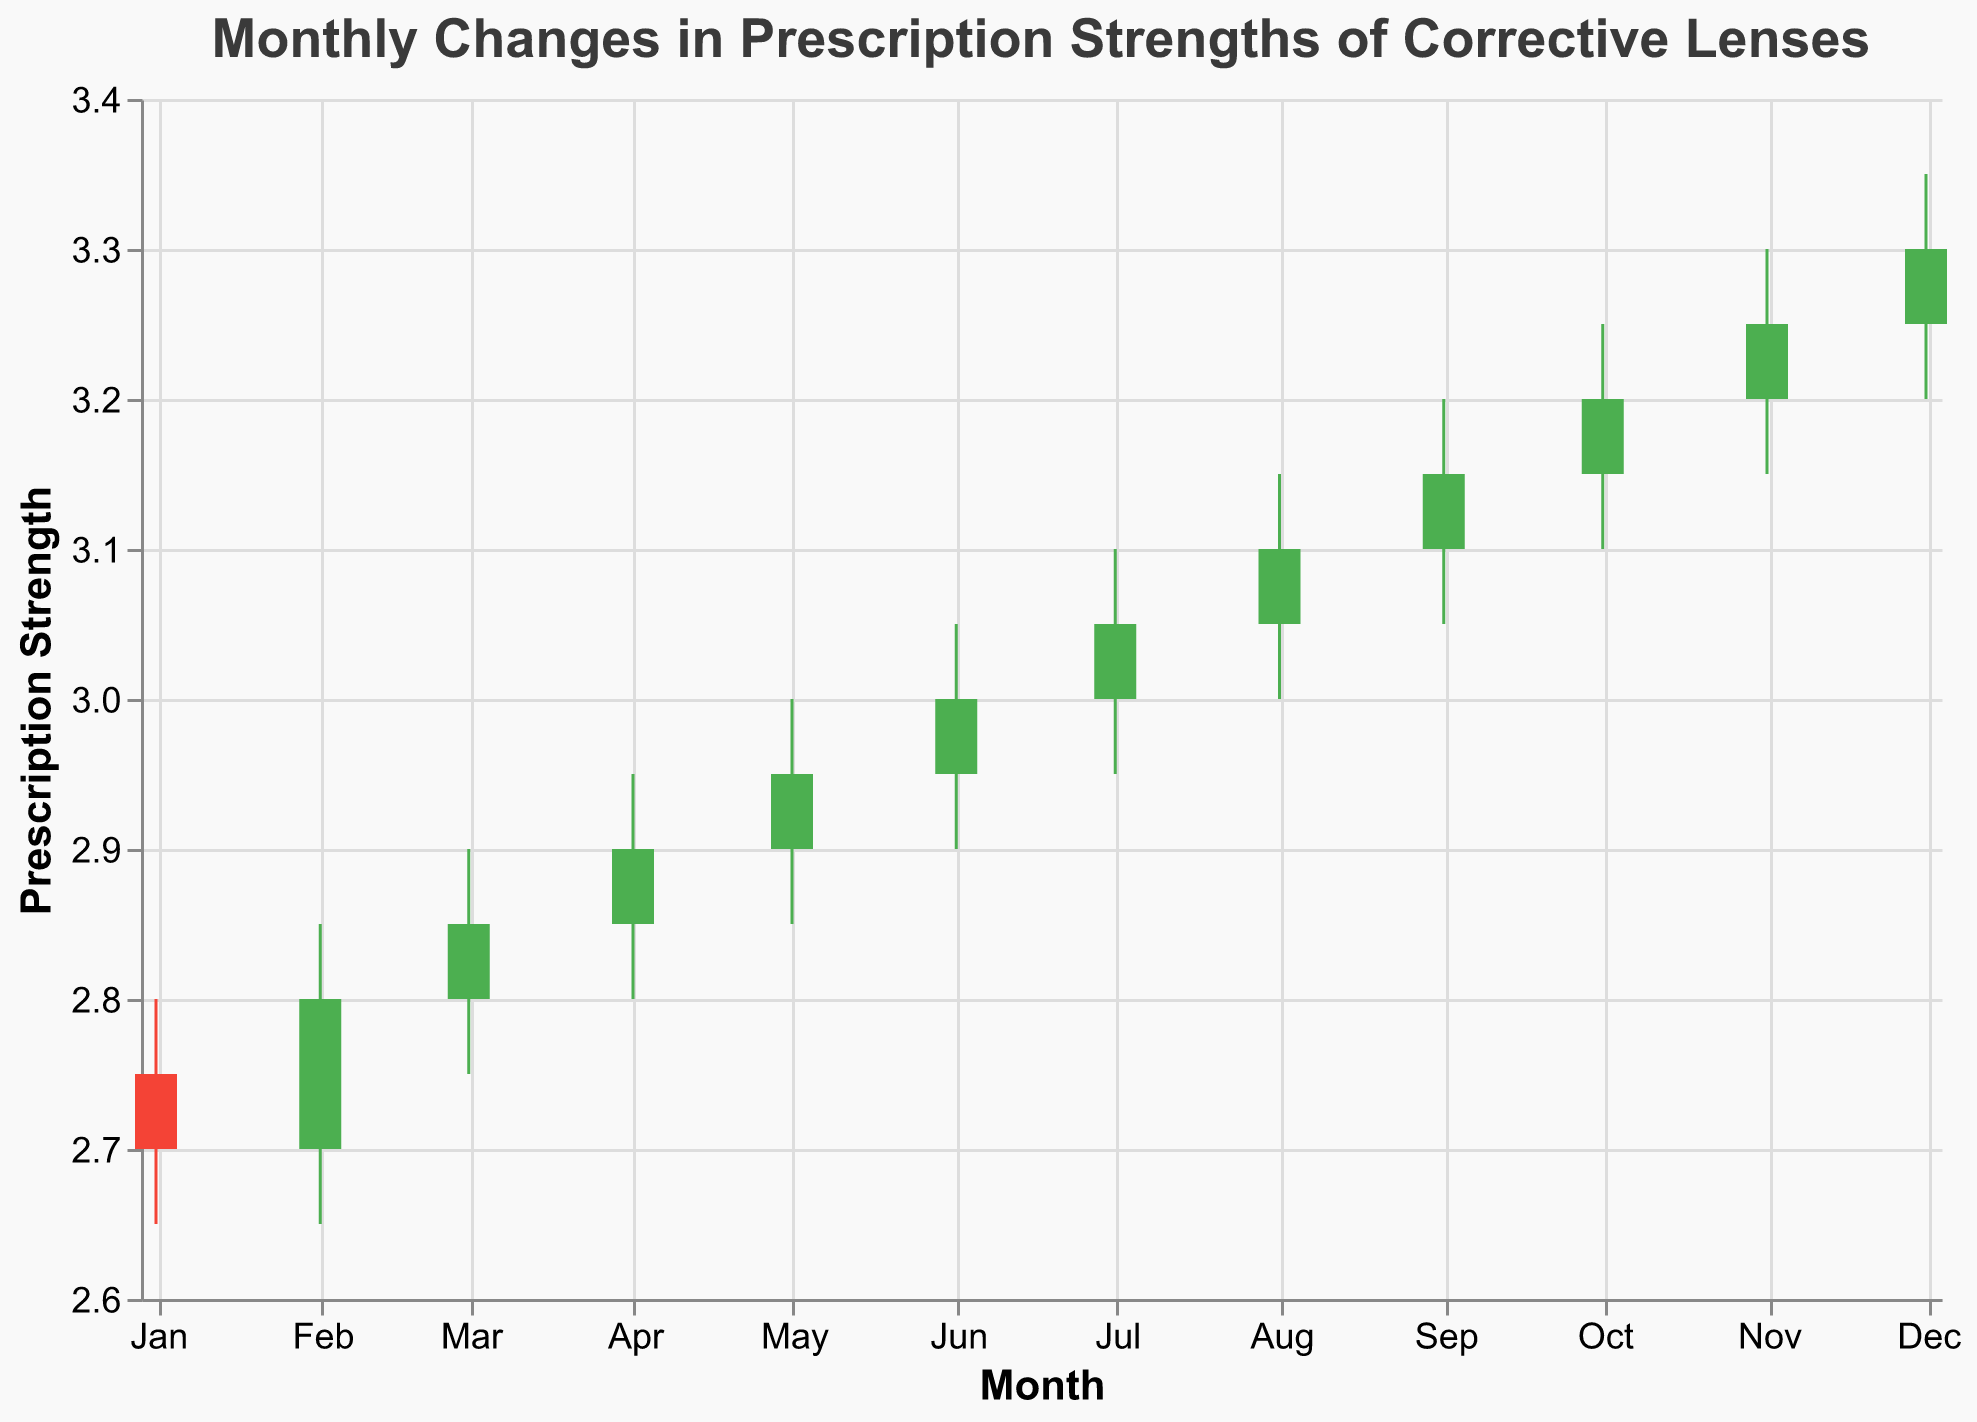What is the title of the figure? The title is displayed at the top of the figure and is usually a brief description of the data or analysis being presented.
Answer: Monthly Changes in Prescription Strengths of Corrective Lenses How many months are represented in the figure? The x-axis represents the months, and each candlestick represents data for one month. Count the number of candlesticks to determine the number of months.
Answer: 12 What does a green candlestick represent in this figure? A green candlestick means that the closing prescription strength is higher than the opening prescription strength for that month.
Answer: The closing strength is higher than the opening strength What was the highest prescription strength reached in 2023? To find the highest prescription strength, look at the peak values of the highest points for each month. The highest value is in December.
Answer: 3.35 In which month was the opening prescription strength the lowest? Identify the lowest value among the opening prescription strengths for each month. The lowest value appears in January and February.
Answer: January and February What is the range of the prescription strengths for October 2023? The range is calculated by subtracting the lowest value from the highest value within a specific month. For October, the high is 3.25 and the low is 3.10, so 3.25 - 3.10 = 0.15
Answer: 0.15 By how much did the prescription strength increase from January to December 2023? Find the difference in the closing prescription strength between December and January. December's closing value is 3.30 and January's is 2.70, so 3.30 - 2.70 = 0.60
Answer: 0.60 Which months showed the largest increase in prescription strength from their opening to closing values? Calculate the difference between the open and close values for each month and find the largest difference. The largest increase is from January (2.75 - 2.70 = -0.05), February (2.80 - 2.70 = 0.10), and others.
Answer: February In which month did the prescription strength experience the greatest volatility? Volatility can be assessed by the difference between the high and low values of each month. The largest difference is in December with high 3.35 and low 3.20, so 3.35 - 3.20 = 0.15
Answer: December Is there a general trend in the prescription strengths over the year? Observe the overall movement of the closing values from January to December. There is a consistent increase in prescription strength over the months.
Answer: Increasing trend 